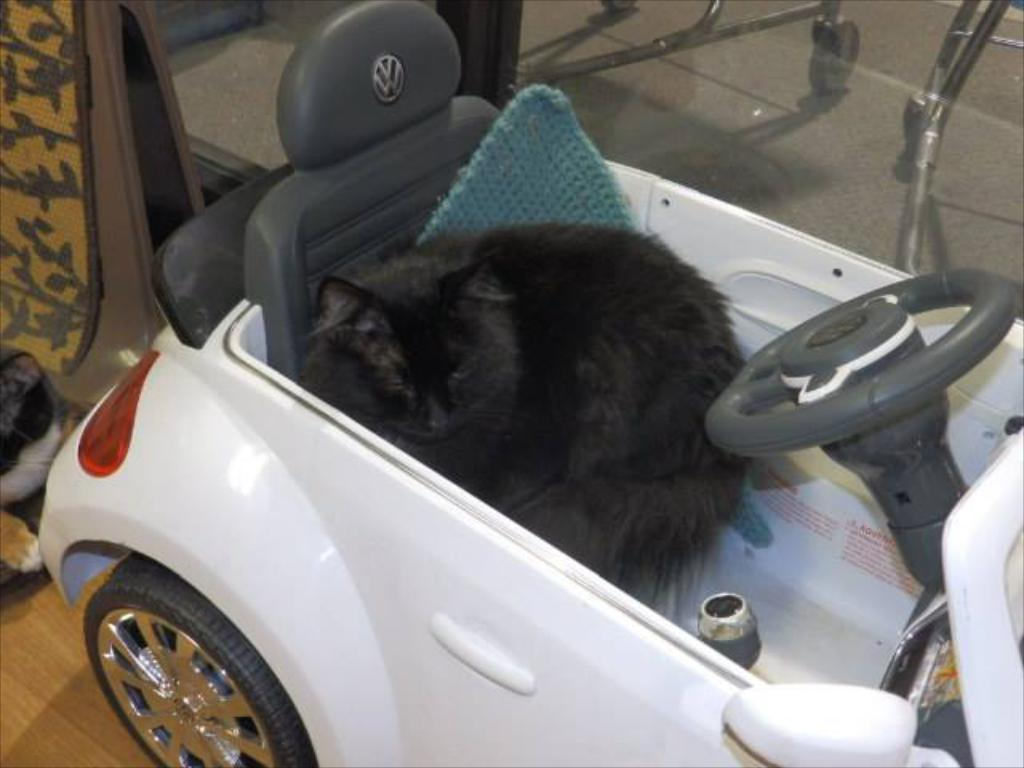What type of animal is in the image? There is a cat in the image. Where is the cat located in the image? The cat is sitting in a car. How many apples can be seen in the image? There are no apples present in the image. What color is the chalk used to draw on the car? There is no chalk or drawing on the car in the image. 